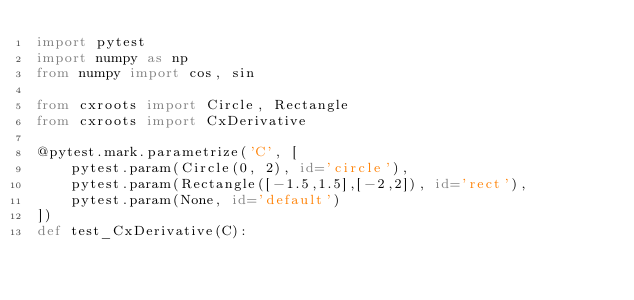Convert code to text. <code><loc_0><loc_0><loc_500><loc_500><_Python_>import pytest
import numpy as np
from numpy import cos, sin

from cxroots import Circle, Rectangle
from cxroots import CxDerivative

@pytest.mark.parametrize('C', [
    pytest.param(Circle(0, 2), id='circle'),
    pytest.param(Rectangle([-1.5,1.5],[-2,2]), id='rect'),
    pytest.param(None, id='default')
])
def test_CxDerivative(C):</code> 